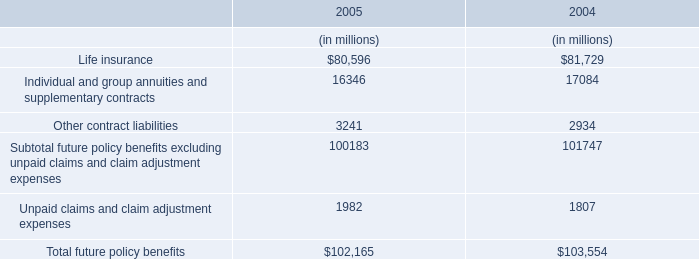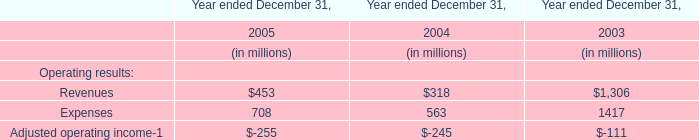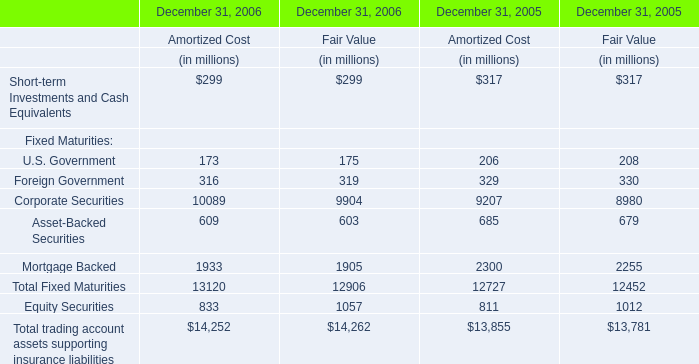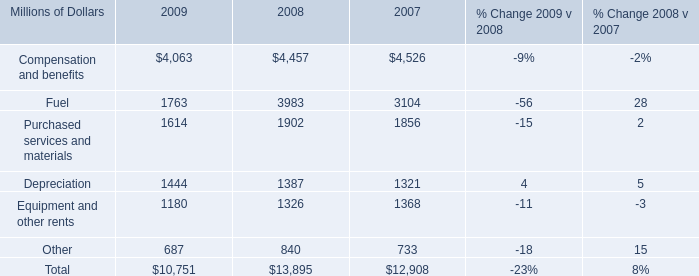Which year is U.S. Government for Amortized Cost greater than 200? 
Answer: 2005. 